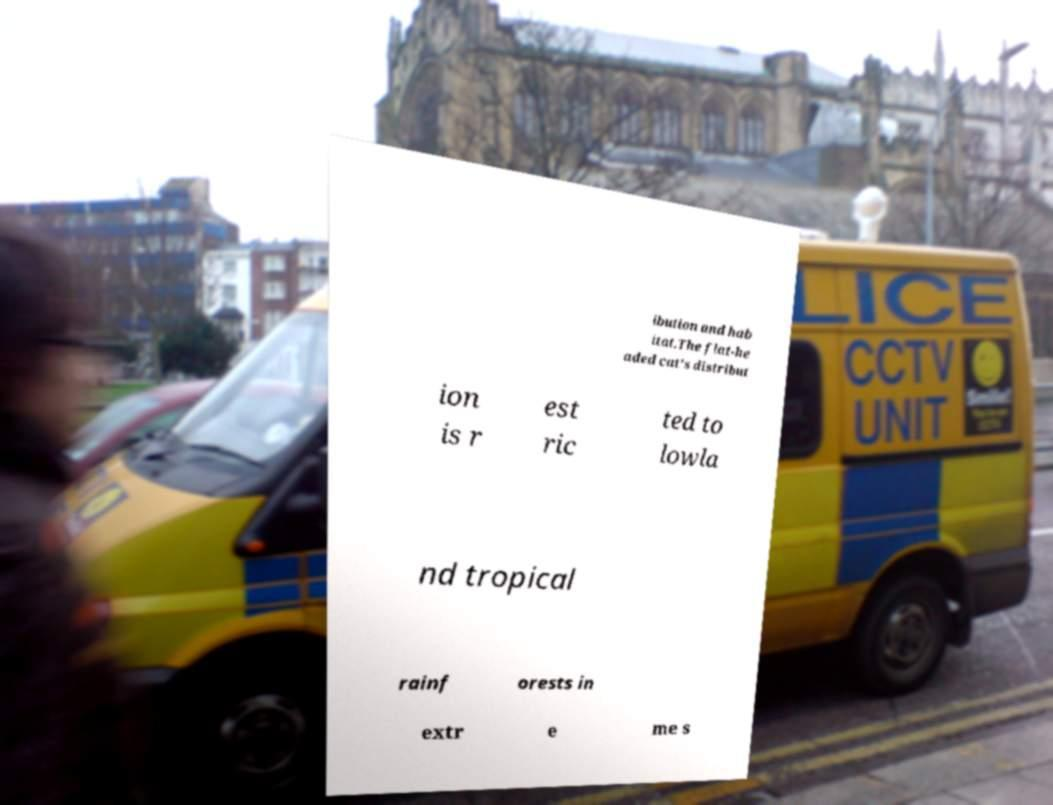Can you read and provide the text displayed in the image?This photo seems to have some interesting text. Can you extract and type it out for me? ibution and hab itat.The flat-he aded cat's distribut ion is r est ric ted to lowla nd tropical rainf orests in extr e me s 